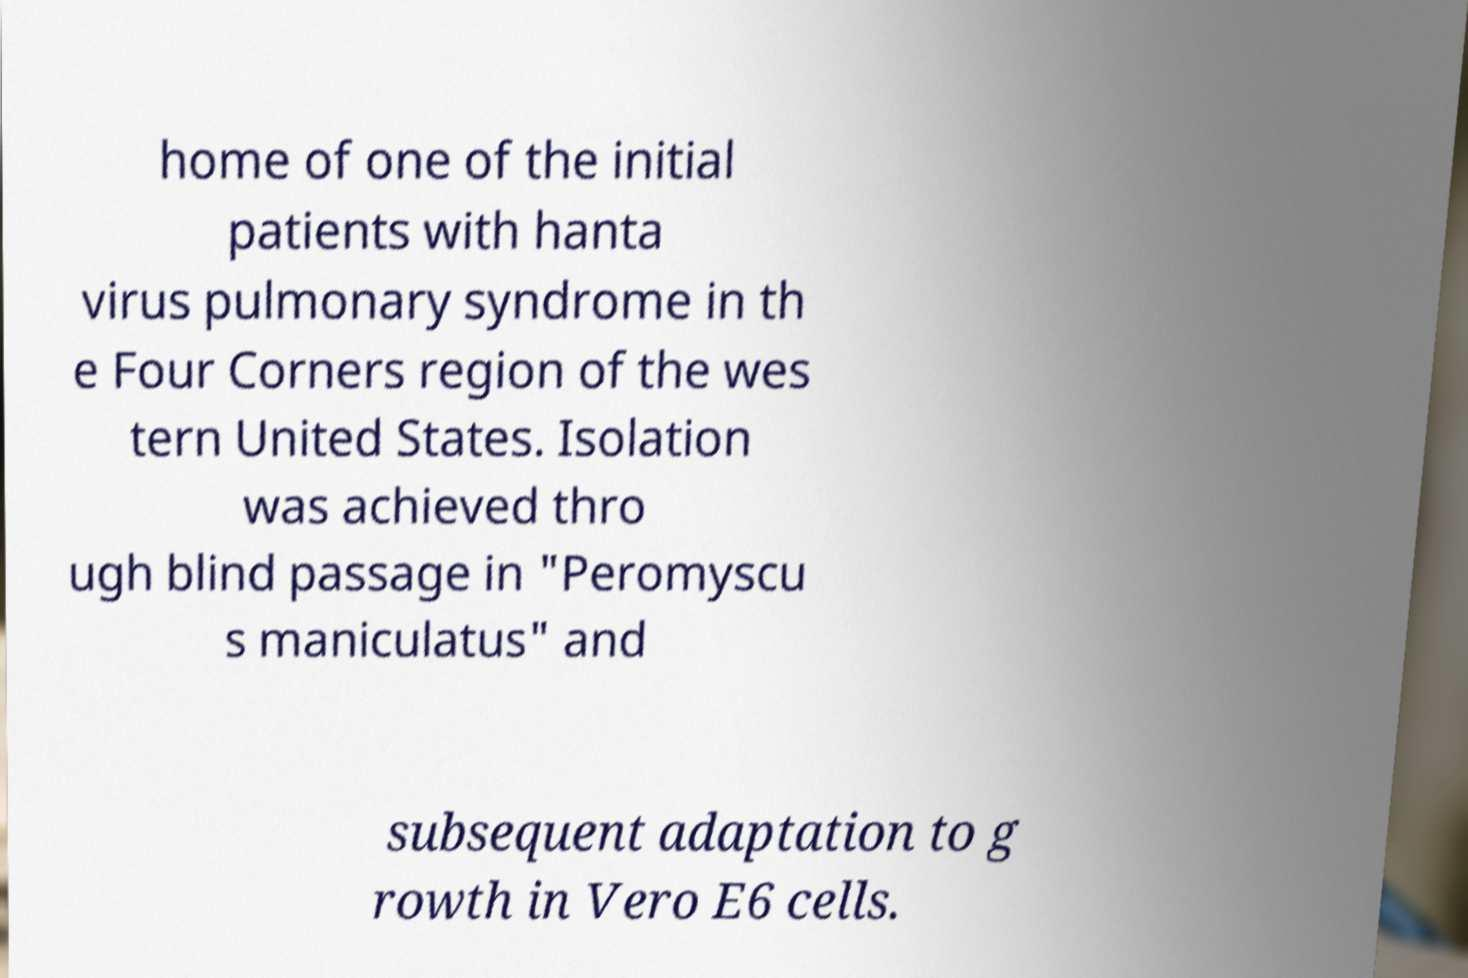Could you extract and type out the text from this image? home of one of the initial patients with hanta virus pulmonary syndrome in th e Four Corners region of the wes tern United States. Isolation was achieved thro ugh blind passage in "Peromyscu s maniculatus" and subsequent adaptation to g rowth in Vero E6 cells. 